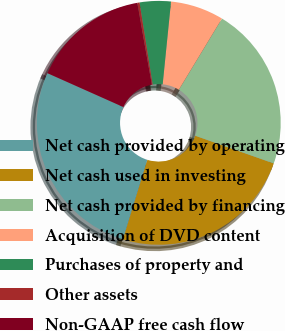Convert chart. <chart><loc_0><loc_0><loc_500><loc_500><pie_chart><fcel>Net cash provided by operating<fcel>Net cash used in investing<fcel>Net cash provided by financing<fcel>Acquisition of DVD content<fcel>Purchases of property and<fcel>Other assets<fcel>Non-GAAP free cash flow<nl><fcel>26.94%<fcel>24.34%<fcel>21.73%<fcel>7.07%<fcel>4.13%<fcel>0.31%<fcel>15.49%<nl></chart> 